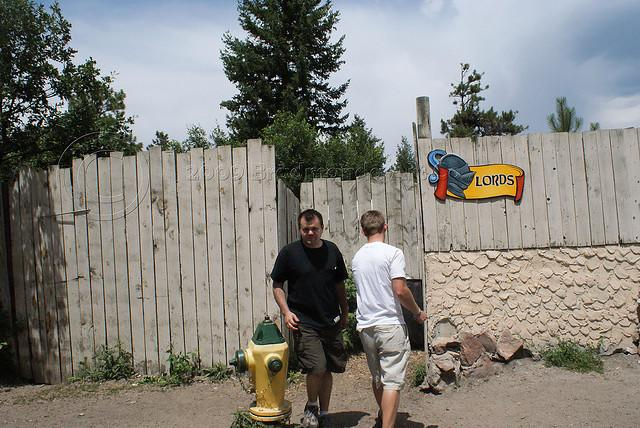What does the man in white need to use? Please explain your reasoning. restroom. He is going to the restroom. 